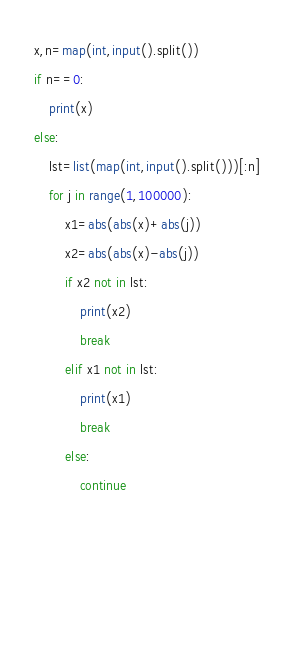<code> <loc_0><loc_0><loc_500><loc_500><_Python_>x,n=map(int,input().split())
if n==0:
    print(x)
else:
    lst=list(map(int,input().split()))[:n]
    for j in range(1,100000):
        x1=abs(abs(x)+abs(j))
        x2=abs(abs(x)-abs(j))
        if x2 not in lst:
            print(x2)
            break
        elif x1 not in lst:
            print(x1)
            break
        else:
            continue
        
        
        
    </code> 